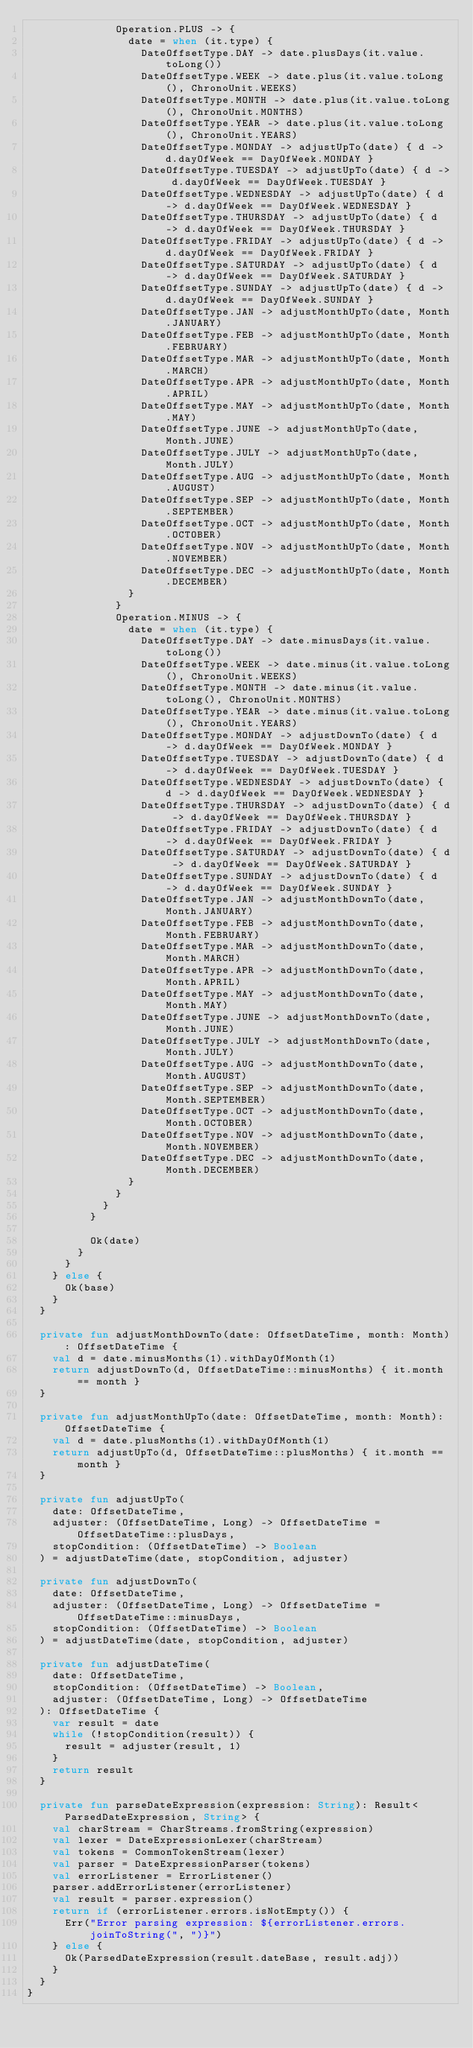<code> <loc_0><loc_0><loc_500><loc_500><_Kotlin_>              Operation.PLUS -> {
                date = when (it.type) {
                  DateOffsetType.DAY -> date.plusDays(it.value.toLong())
                  DateOffsetType.WEEK -> date.plus(it.value.toLong(), ChronoUnit.WEEKS)
                  DateOffsetType.MONTH -> date.plus(it.value.toLong(), ChronoUnit.MONTHS)
                  DateOffsetType.YEAR -> date.plus(it.value.toLong(), ChronoUnit.YEARS)
                  DateOffsetType.MONDAY -> adjustUpTo(date) { d -> d.dayOfWeek == DayOfWeek.MONDAY }
                  DateOffsetType.TUESDAY -> adjustUpTo(date) { d -> d.dayOfWeek == DayOfWeek.TUESDAY }
                  DateOffsetType.WEDNESDAY -> adjustUpTo(date) { d -> d.dayOfWeek == DayOfWeek.WEDNESDAY }
                  DateOffsetType.THURSDAY -> adjustUpTo(date) { d -> d.dayOfWeek == DayOfWeek.THURSDAY }
                  DateOffsetType.FRIDAY -> adjustUpTo(date) { d -> d.dayOfWeek == DayOfWeek.FRIDAY }
                  DateOffsetType.SATURDAY -> adjustUpTo(date) { d -> d.dayOfWeek == DayOfWeek.SATURDAY }
                  DateOffsetType.SUNDAY -> adjustUpTo(date) { d -> d.dayOfWeek == DayOfWeek.SUNDAY }
                  DateOffsetType.JAN -> adjustMonthUpTo(date, Month.JANUARY)
                  DateOffsetType.FEB -> adjustMonthUpTo(date, Month.FEBRUARY)
                  DateOffsetType.MAR -> adjustMonthUpTo(date, Month.MARCH)
                  DateOffsetType.APR -> adjustMonthUpTo(date, Month.APRIL)
                  DateOffsetType.MAY -> adjustMonthUpTo(date, Month.MAY)
                  DateOffsetType.JUNE -> adjustMonthUpTo(date, Month.JUNE)
                  DateOffsetType.JULY -> adjustMonthUpTo(date, Month.JULY)
                  DateOffsetType.AUG -> adjustMonthUpTo(date, Month.AUGUST)
                  DateOffsetType.SEP -> adjustMonthUpTo(date, Month.SEPTEMBER)
                  DateOffsetType.OCT -> adjustMonthUpTo(date, Month.OCTOBER)
                  DateOffsetType.NOV -> adjustMonthUpTo(date, Month.NOVEMBER)
                  DateOffsetType.DEC -> adjustMonthUpTo(date, Month.DECEMBER)
                }
              }
              Operation.MINUS -> {
                date = when (it.type) {
                  DateOffsetType.DAY -> date.minusDays(it.value.toLong())
                  DateOffsetType.WEEK -> date.minus(it.value.toLong(), ChronoUnit.WEEKS)
                  DateOffsetType.MONTH -> date.minus(it.value.toLong(), ChronoUnit.MONTHS)
                  DateOffsetType.YEAR -> date.minus(it.value.toLong(), ChronoUnit.YEARS)
                  DateOffsetType.MONDAY -> adjustDownTo(date) { d -> d.dayOfWeek == DayOfWeek.MONDAY }
                  DateOffsetType.TUESDAY -> adjustDownTo(date) { d -> d.dayOfWeek == DayOfWeek.TUESDAY }
                  DateOffsetType.WEDNESDAY -> adjustDownTo(date) { d -> d.dayOfWeek == DayOfWeek.WEDNESDAY }
                  DateOffsetType.THURSDAY -> adjustDownTo(date) { d -> d.dayOfWeek == DayOfWeek.THURSDAY }
                  DateOffsetType.FRIDAY -> adjustDownTo(date) { d -> d.dayOfWeek == DayOfWeek.FRIDAY }
                  DateOffsetType.SATURDAY -> adjustDownTo(date) { d -> d.dayOfWeek == DayOfWeek.SATURDAY }
                  DateOffsetType.SUNDAY -> adjustDownTo(date) { d -> d.dayOfWeek == DayOfWeek.SUNDAY }
                  DateOffsetType.JAN -> adjustMonthDownTo(date, Month.JANUARY)
                  DateOffsetType.FEB -> adjustMonthDownTo(date, Month.FEBRUARY)
                  DateOffsetType.MAR -> adjustMonthDownTo(date, Month.MARCH)
                  DateOffsetType.APR -> adjustMonthDownTo(date, Month.APRIL)
                  DateOffsetType.MAY -> adjustMonthDownTo(date, Month.MAY)
                  DateOffsetType.JUNE -> adjustMonthDownTo(date, Month.JUNE)
                  DateOffsetType.JULY -> adjustMonthDownTo(date, Month.JULY)
                  DateOffsetType.AUG -> adjustMonthDownTo(date, Month.AUGUST)
                  DateOffsetType.SEP -> adjustMonthDownTo(date, Month.SEPTEMBER)
                  DateOffsetType.OCT -> adjustMonthDownTo(date, Month.OCTOBER)
                  DateOffsetType.NOV -> adjustMonthDownTo(date, Month.NOVEMBER)
                  DateOffsetType.DEC -> adjustMonthDownTo(date, Month.DECEMBER)
                }
              }
            }
          }

          Ok(date)
        }
      }
    } else {
      Ok(base)
    }
  }

  private fun adjustMonthDownTo(date: OffsetDateTime, month: Month): OffsetDateTime {
    val d = date.minusMonths(1).withDayOfMonth(1)
    return adjustDownTo(d, OffsetDateTime::minusMonths) { it.month == month }
  }

  private fun adjustMonthUpTo(date: OffsetDateTime, month: Month): OffsetDateTime {
    val d = date.plusMonths(1).withDayOfMonth(1)
    return adjustUpTo(d, OffsetDateTime::plusMonths) { it.month == month }
  }

  private fun adjustUpTo(
    date: OffsetDateTime,
    adjuster: (OffsetDateTime, Long) -> OffsetDateTime = OffsetDateTime::plusDays,
    stopCondition: (OffsetDateTime) -> Boolean
  ) = adjustDateTime(date, stopCondition, adjuster)

  private fun adjustDownTo(
    date: OffsetDateTime,
    adjuster: (OffsetDateTime, Long) -> OffsetDateTime = OffsetDateTime::minusDays,
    stopCondition: (OffsetDateTime) -> Boolean
  ) = adjustDateTime(date, stopCondition, adjuster)

  private fun adjustDateTime(
    date: OffsetDateTime,
    stopCondition: (OffsetDateTime) -> Boolean,
    adjuster: (OffsetDateTime, Long) -> OffsetDateTime
  ): OffsetDateTime {
    var result = date
    while (!stopCondition(result)) {
      result = adjuster(result, 1)
    }
    return result
  }

  private fun parseDateExpression(expression: String): Result<ParsedDateExpression, String> {
    val charStream = CharStreams.fromString(expression)
    val lexer = DateExpressionLexer(charStream)
    val tokens = CommonTokenStream(lexer)
    val parser = DateExpressionParser(tokens)
    val errorListener = ErrorListener()
    parser.addErrorListener(errorListener)
    val result = parser.expression()
    return if (errorListener.errors.isNotEmpty()) {
      Err("Error parsing expression: ${errorListener.errors.joinToString(", ")}")
    } else {
      Ok(ParsedDateExpression(result.dateBase, result.adj))
    }
  }
}
</code> 